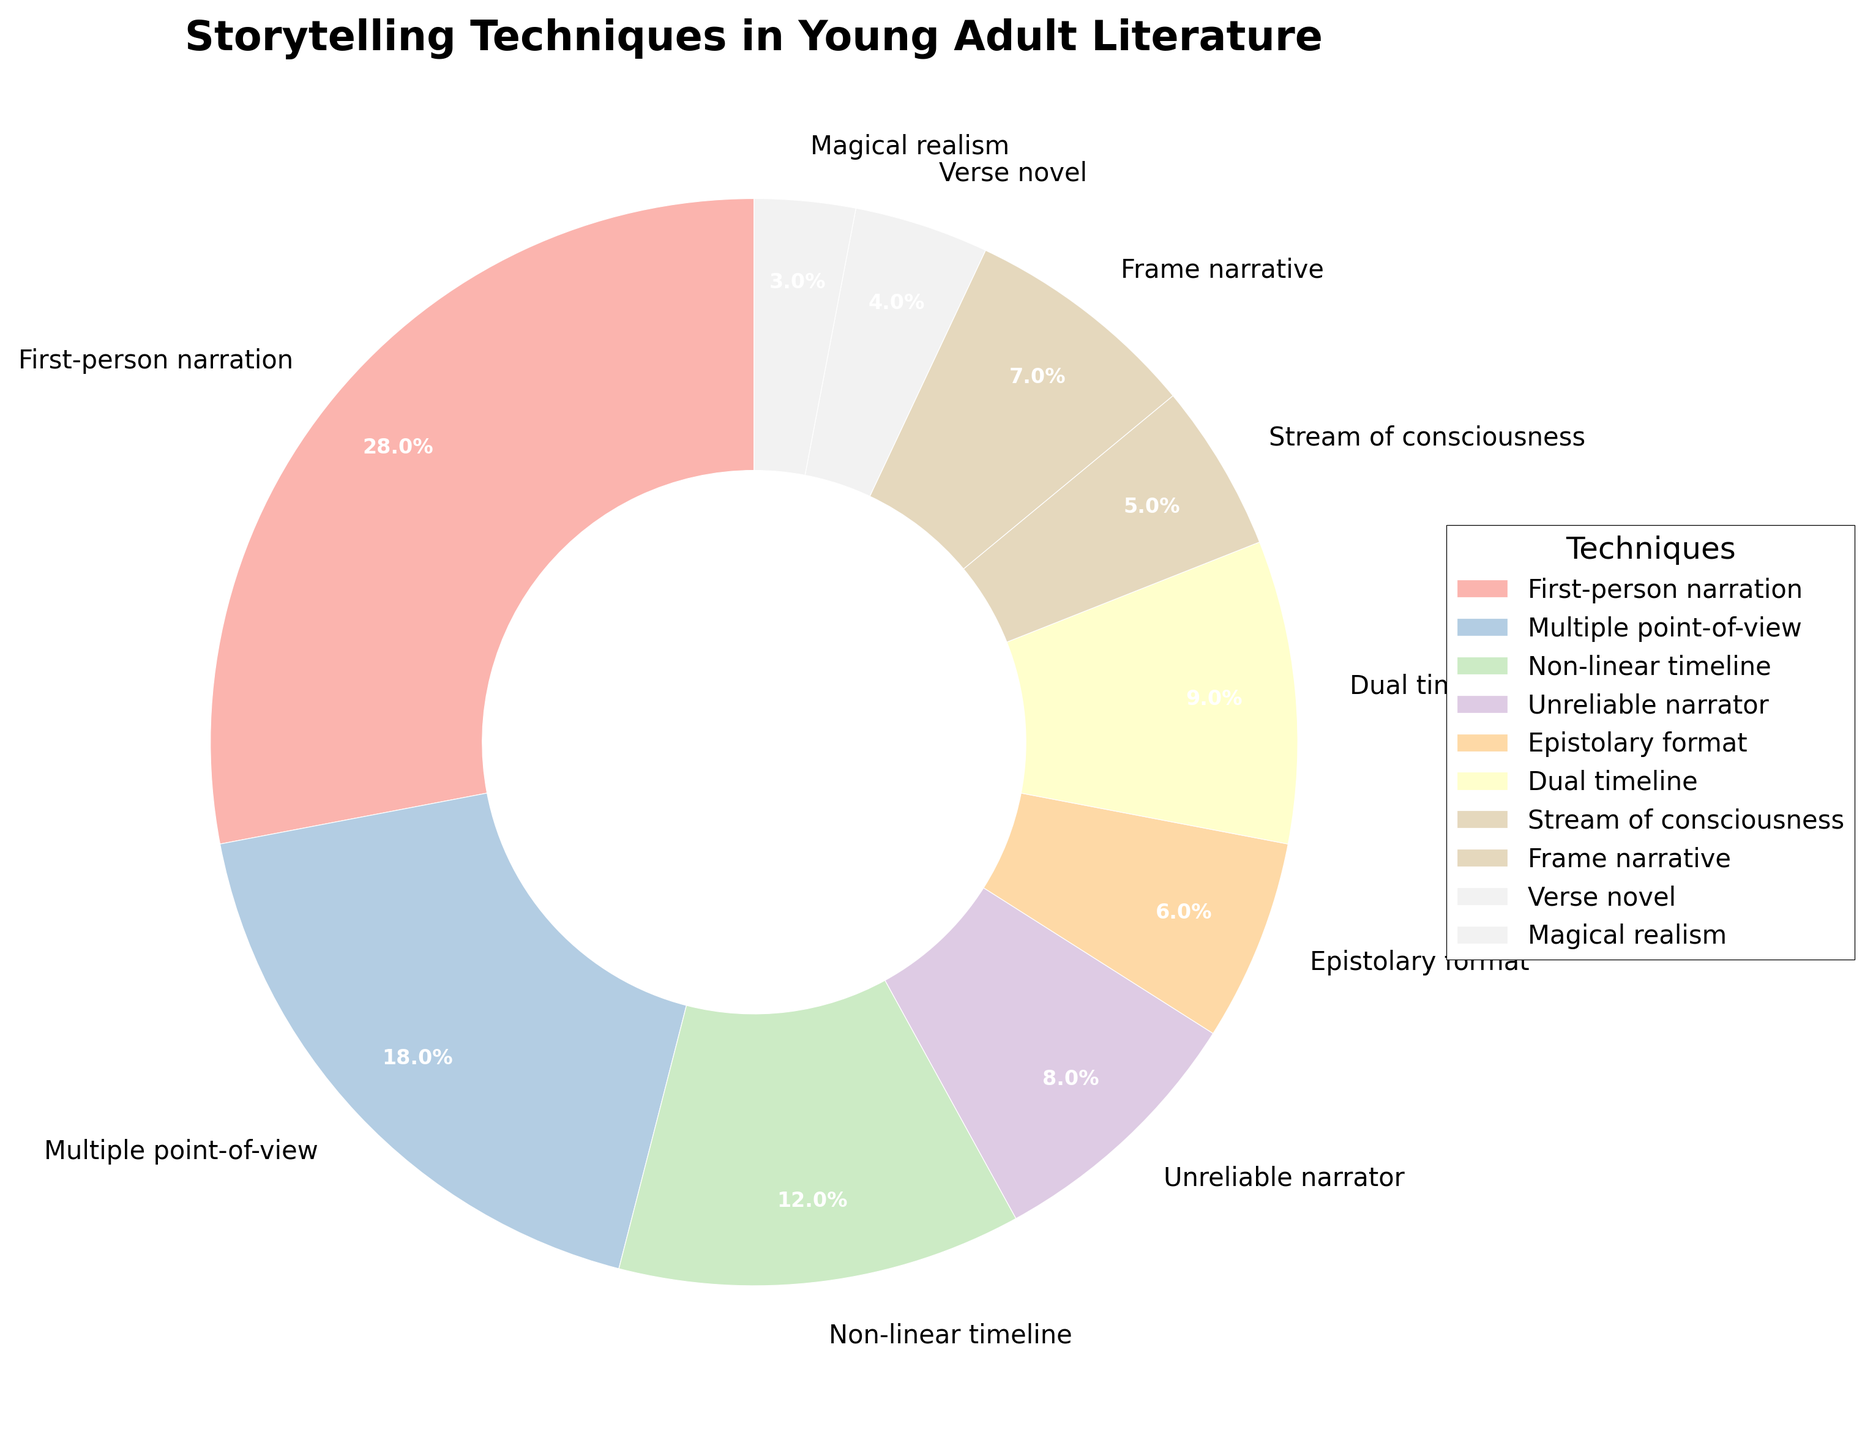Which storytelling technique is used the most? By looking at the pie chart, each segment's size represents the percentage of use for each technique. The largest segment corresponds to First-person narration.
Answer: First-person narration What is the combined percentage of Epistolary format and Verse novel? To find the combined percentage, add the individual percentages of Epistolary format (6%) and Verse novel (4%).
Answer: 10% What is the difference in percentage between First-person narration and Dual timeline? The percentage for each technique is shown on the pie chart. Subtract the percentage of Dual timeline (9%) from First-person narration (28%).
Answer: 19% Which techniques have a smaller percentage than Non-linear timeline? The pie chart shows that Non-linear timeline is 12%. Techniques with smaller percentages are Unreliable narrator (8%), Epistolary format (6%), Stream of consciousness (5%), Frame narrative (7%), Verse novel (4%), and Magical realism (3%).
Answer: Unreliable narrator, Epistolary format, Stream of consciousness, Frame narrative, Verse novel, Magical realism How does the use of Multiple point-of-view compare to Non-linear timeline? Compare the pie chart segments for Multiple point-of-view (18%) and Non-linear timeline (12%). Multiple point-of-view has a larger percentage than Non-linear timeline.
Answer: Multiple point-of-view is more used What's the difference between the sum of the percentages of First-person narration and Stream of consciousness and the percentage of Multiple point-of-view? Sum the percentages of First-person narration (28%) and Stream of consciousness (5%) to get 33%. Then subtract the percentage of Multiple point-of-view (18%) from this sum (33% - 18% = 15%).
Answer: 15% Which technique has the smallest usage percentage, and what is it? The smallest segment on the pie chart corresponds to the technique with the smallest percentage. It is Magical realism with 3%.
Answer: Magical realism, 3% What percentage of techniques fall under single-digit usage? From the pie chart, techniques with single-digit usage are Non-linear timeline (12%) is excluded. Those included: Unreliable narrator (8%), Epistolary format (6%), Dual timeline (9%), Stream of consciousness (5%), Frame narrative (7%), Verse novel (4%), and Magical realism (3%). Summing these percentages: (8 + 6 + 9 + 5 + 7 + 4 + 3) results in 42%.
Answer: 42% Which techniques together make up more than half of the total usage? From the pie chart, identify the techniques and their percentages: First-person narration (28%), Multiple point-of-view (18%) and Non-linear timeline (12%). These together sum (28 + 18 + 12) = 58%, which is more than half.
Answer: First-person narration, Multiple point-of-view, Non-linear timeline 